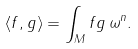Convert formula to latex. <formula><loc_0><loc_0><loc_500><loc_500>\langle f , g \rangle = \int _ { M } f g \, \omega ^ { n } .</formula> 